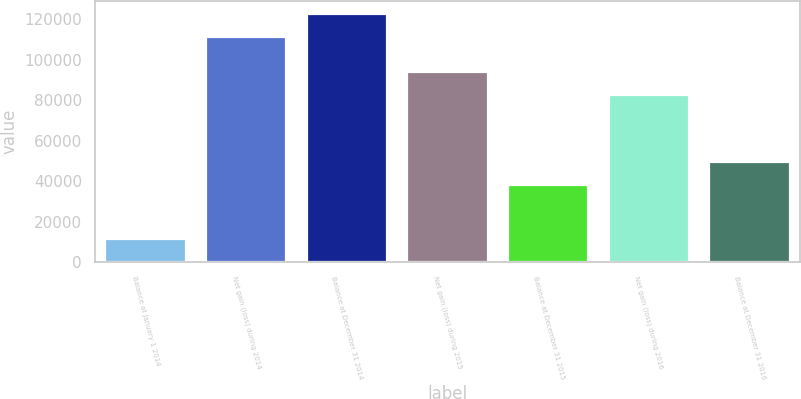<chart> <loc_0><loc_0><loc_500><loc_500><bar_chart><fcel>Balance at January 1 2014<fcel>Net gain (loss) during 2014<fcel>Balance at December 31 2014<fcel>Net gain (loss) during 2015<fcel>Balance at December 31 2015<fcel>Net gain (loss) during 2016<fcel>Balance at December 31 2016<nl><fcel>11294<fcel>111389<fcel>122683<fcel>93961.9<fcel>38166<fcel>82823<fcel>49304.9<nl></chart> 